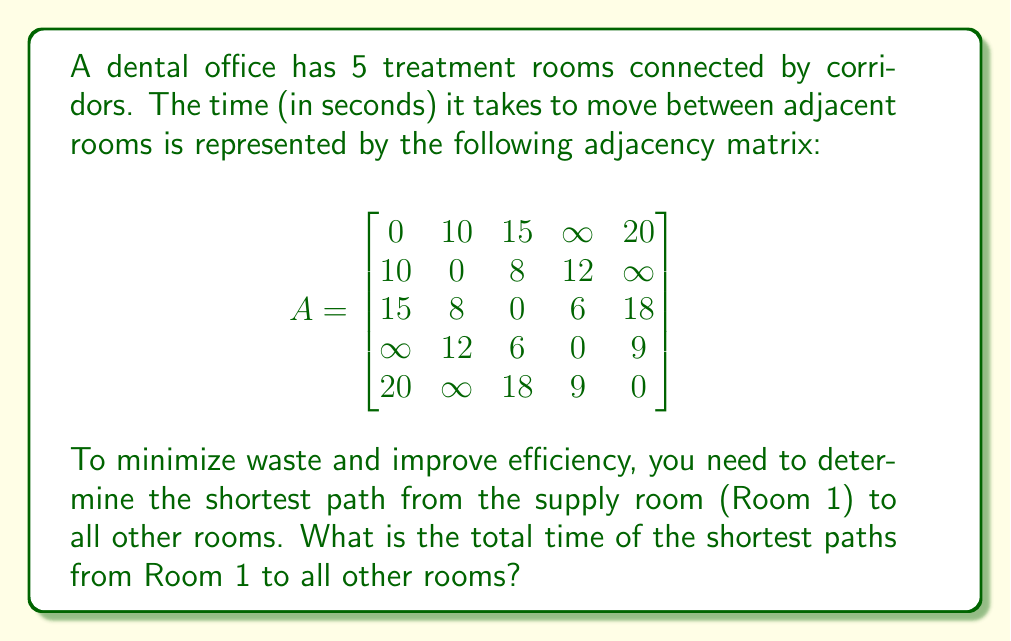Solve this math problem. To solve this problem, we'll use Dijkstra's algorithm to find the shortest paths from Room 1 to all other rooms in the dental office. Here's the step-by-step process:

1) Initialize:
   - Distance to Room 1 (source) = 0
   - Distance to all other rooms = $\infty$
   - Set of unvisited rooms = {1, 2, 3, 4, 5}

2) Start with Room 1:
   - Update distances: Room 2 (10s), Room 3 (15s), Room 5 (20s)
   - Mark Room 1 as visited
   - Unvisited set: {2, 3, 4, 5}

3) Select Room 2 (shortest distance from unvisited set):
   - Update distances: Room 3 (min(15, 10+8) = 15s), Room 4 (10+12 = 22s)
   - Mark Room 2 as visited
   - Unvisited set: {3, 4, 5}

4) Select Room 3:
   - Update distances: Room 4 (min(22, 15+6) = 21s), Room 5 (min(20, 15+18) = 20s)
   - Mark Room 3 as visited
   - Unvisited set: {4, 5}

5) Select Room 5:
   - Update distances: Room 4 (min(21, 20+9) = 20s)
   - Mark Room 5 as visited
   - Unvisited set: {4}

6) Select Room 4:
   - No updates needed
   - Mark Room 4 as visited
   - Unvisited set: {}

Final shortest distances from Room 1:
- Room 2: 10s
- Room 3: 15s
- Room 4: 20s
- Room 5: 20s

The total time of the shortest paths from Room 1 to all other rooms is the sum of these distances:
$$10 + 15 + 20 + 20 = 65\text{ seconds}$$
Answer: 65 seconds 